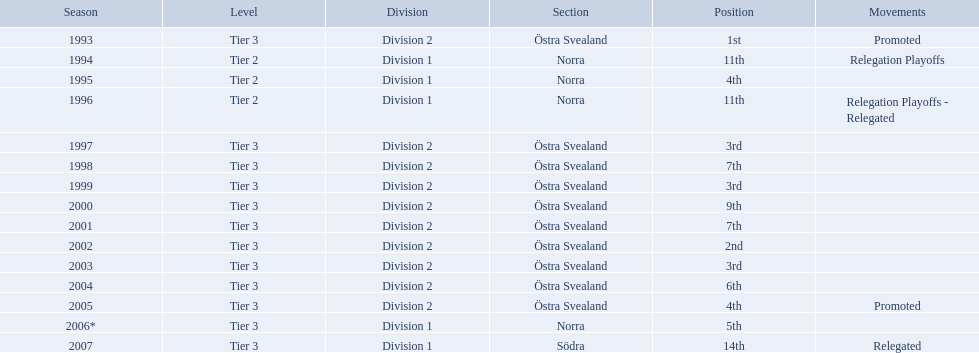During which season was visby if gute fk the winner of division 2 tier 3? 1993. 